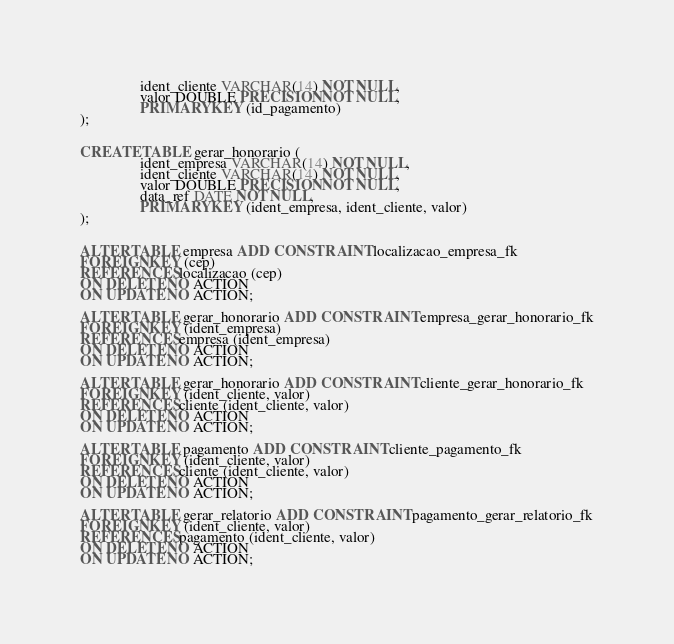Convert code to text. <code><loc_0><loc_0><loc_500><loc_500><_SQL_>                ident_cliente VARCHAR(14) NOT NULL,
                valor DOUBLE PRECISION NOT NULL,
                PRIMARY KEY (id_pagamento)
);


CREATE TABLE gerar_honorario (
                ident_empresa VARCHAR(14) NOT NULL,
                ident_cliente VARCHAR(14) NOT NULL,
                valor DOUBLE PRECISION NOT NULL,
                data_ref DATE NOT NULL,
                PRIMARY KEY (ident_empresa, ident_cliente, valor)
);


ALTER TABLE empresa ADD CONSTRAINT localizacao_empresa_fk
FOREIGN KEY (cep)
REFERENCES localizacao (cep)
ON DELETE NO ACTION
ON UPDATE NO ACTION;

ALTER TABLE gerar_honorario ADD CONSTRAINT empresa_gerar_honorario_fk
FOREIGN KEY (ident_empresa)
REFERENCES empresa (ident_empresa)
ON DELETE NO ACTION
ON UPDATE NO ACTION;

ALTER TABLE gerar_honorario ADD CONSTRAINT cliente_gerar_honorario_fk
FOREIGN KEY (ident_cliente, valor)
REFERENCES cliente (ident_cliente, valor)
ON DELETE NO ACTION
ON UPDATE NO ACTION;

ALTER TABLE pagamento ADD CONSTRAINT cliente_pagamento_fk
FOREIGN KEY (ident_cliente, valor)
REFERENCES cliente (ident_cliente, valor)
ON DELETE NO ACTION
ON UPDATE NO ACTION;

ALTER TABLE gerar_relatorio ADD CONSTRAINT pagamento_gerar_relatorio_fk
FOREIGN KEY (ident_cliente, valor)
REFERENCES pagamento (ident_cliente, valor)
ON DELETE NO ACTION
ON UPDATE NO ACTION;
</code> 